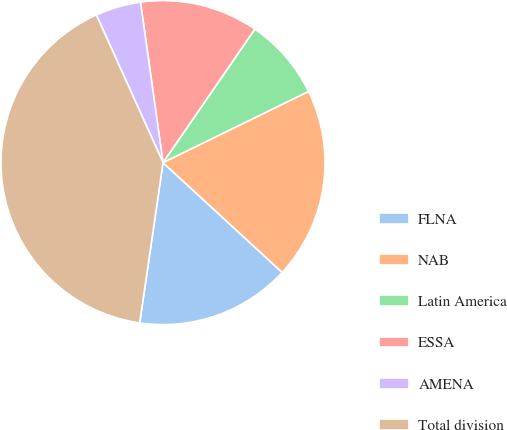Convert chart. <chart><loc_0><loc_0><loc_500><loc_500><pie_chart><fcel>FLNA<fcel>NAB<fcel>Latin America<fcel>ESSA<fcel>AMENA<fcel>Total division<nl><fcel>15.45%<fcel>19.09%<fcel>8.17%<fcel>11.81%<fcel>4.53%<fcel>40.95%<nl></chart> 